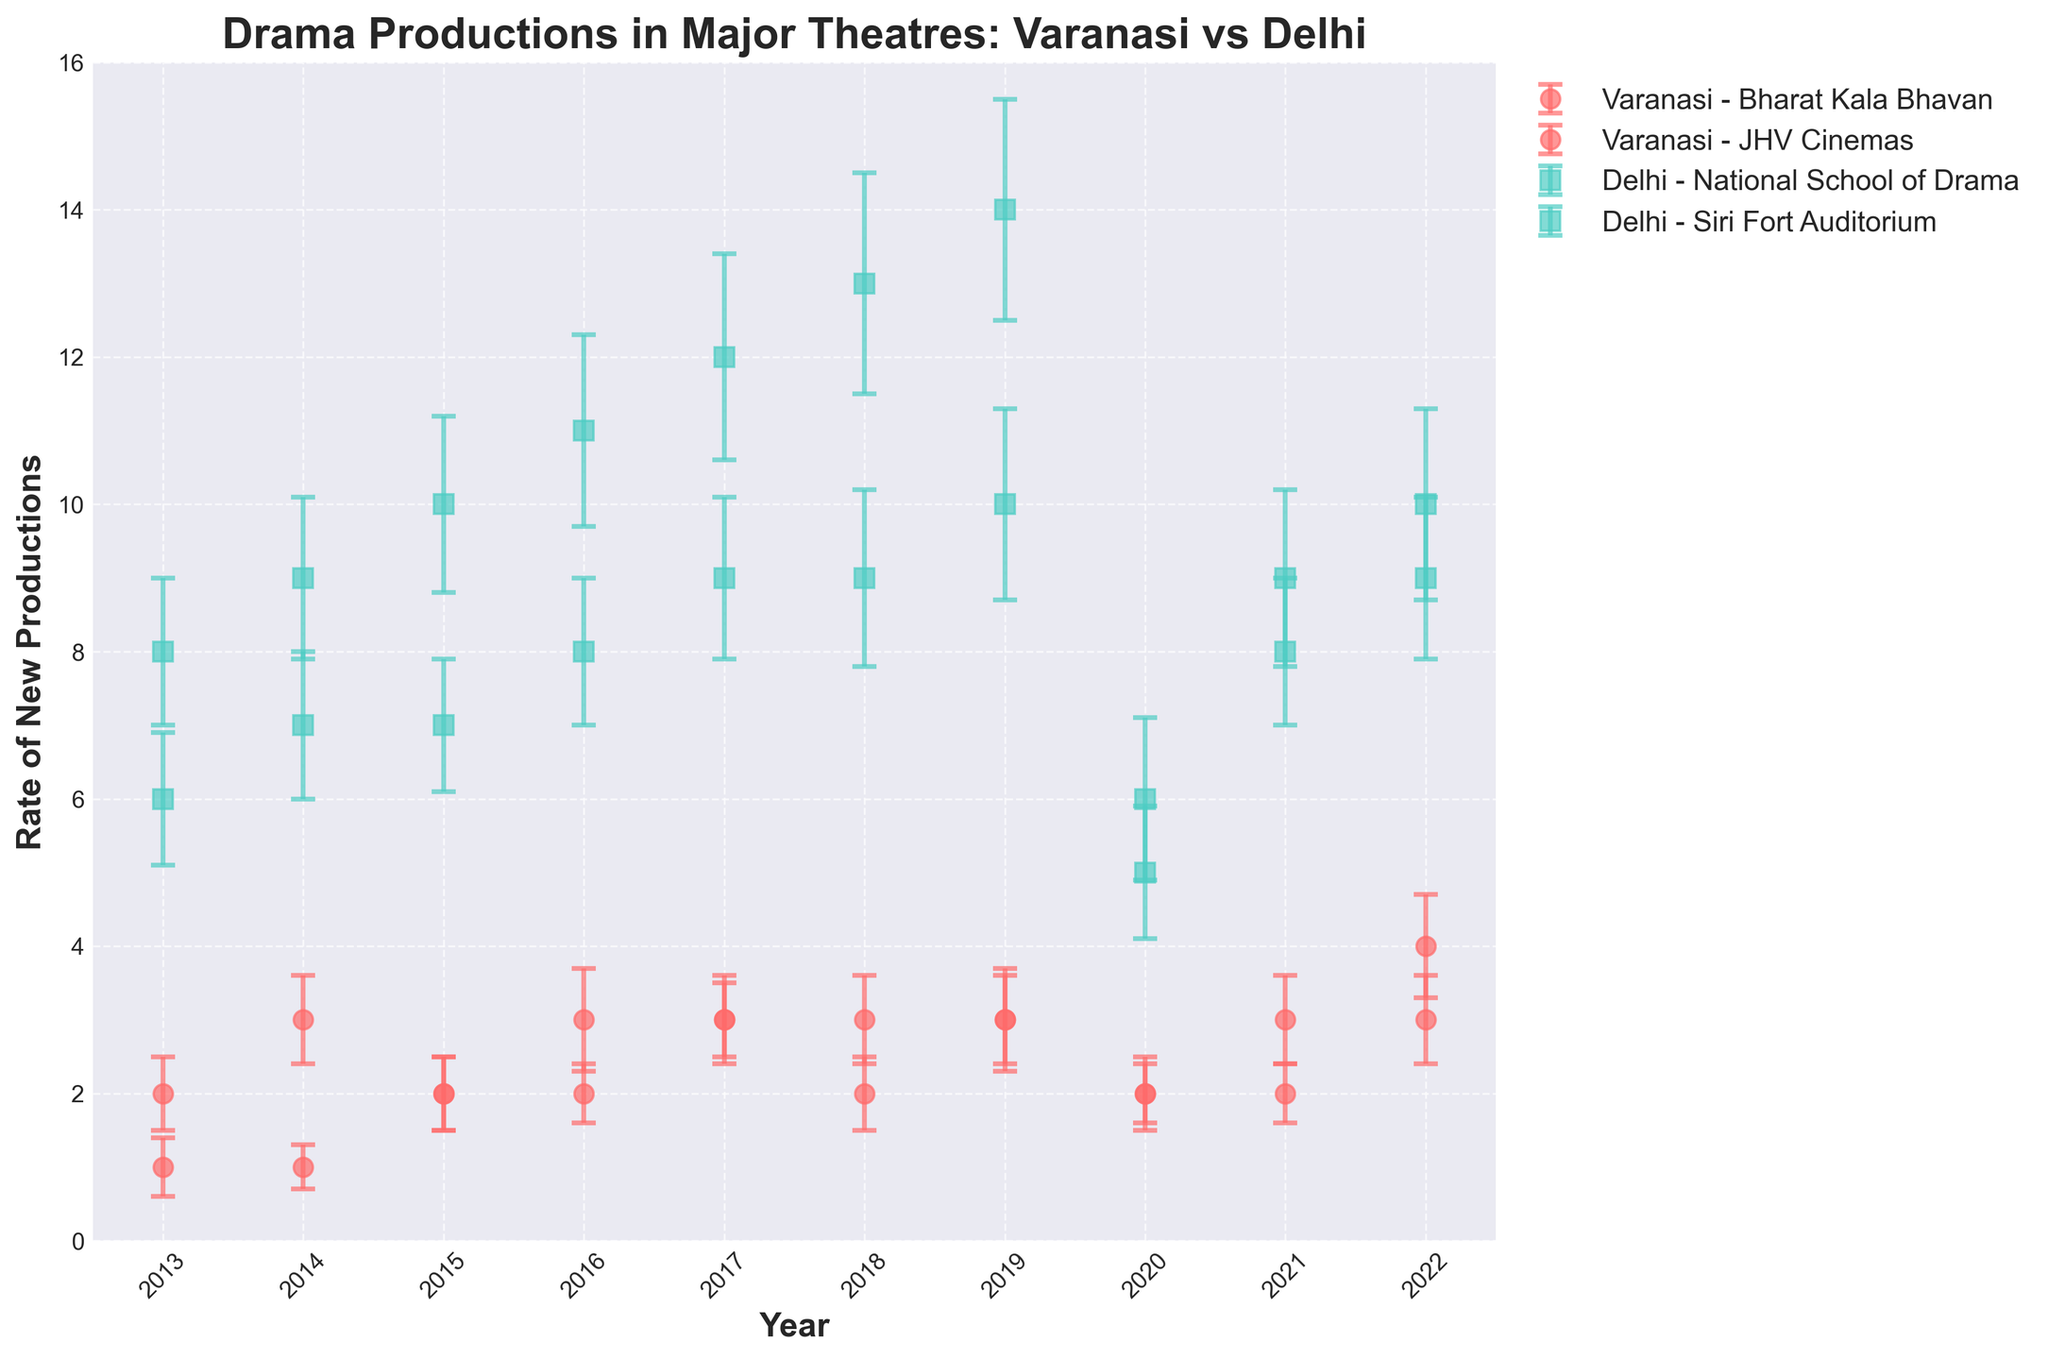What is the title of the figure? The title of the figure is displayed at the top and reads, "Drama Productions in Major Theatres: Varanasi vs Delhi".
Answer: Drama Productions in Major Theatres: Varanasi vs Delhi How many theatres from Delhi are represented in the figure? To find the number of theatres from Delhi, look at the different labels in the legend corresponding to Delhi. There are two theatres: "Delhi - National School of Drama" and "Delhi - Siri Fort Auditorium".
Answer: 2 Which city had a higher rate of new drama productions in 2019, Varanasi or Delhi? Inspect the lines for both Varanasi and Delhi in the year 2019. Delhi's National School of Drama had 14, and Siri Fort Auditorium had 10, while Varanasi's Bharat Kala Bhavan had 3, and JHV Cinemas had 3. Thus, Delhi had higher rates overall.
Answer: Delhi Did any theatre in Varanasi or Delhi have a rate of new productions drop significantly in 2020? Look at the error bars for both cities. The National School of Drama in Delhi had a significant drop from 14 in 2019 to 6 in 2020.
Answer: Yes What is the average rate of new productions over the decade for Bharat Kala Bhavan in Varanasi? First, observe the data points for Bharat Kala Bhavan: 2, 3, 2, 3, 3, 3, 2, 3, 3, 3. Summing these values gives 27. There are 10 years, so the average is 27/10 = 2.7.
Answer: 2.7 Between 2017 and 2020, which theatre in Delhi showed the most fluctuation in the rate of new drama productions? Check the error bars for both Delhi theatres between 2017 and 2020. The National School of Drama went from 12 in 2017 to 13 in 2018, 14 in 2019, and then dropped to 6 in 2020. This shows the most fluctuation.
Answer: National School of Drama How does the error size for Bharat Kala Bhavan compare to JHV Cinemas in Varanasi in 2013? Look at the length of the error bars for both theatres in Varanasi in 2013. Bharat Kala Bhavan has an error of 0.5, while JHV Cinemas has an error of 0.4. Therefore, Bharat Kala Bhavan has a slightly larger error bar.
Answer: Bharat Kala Bhavan's error is larger 